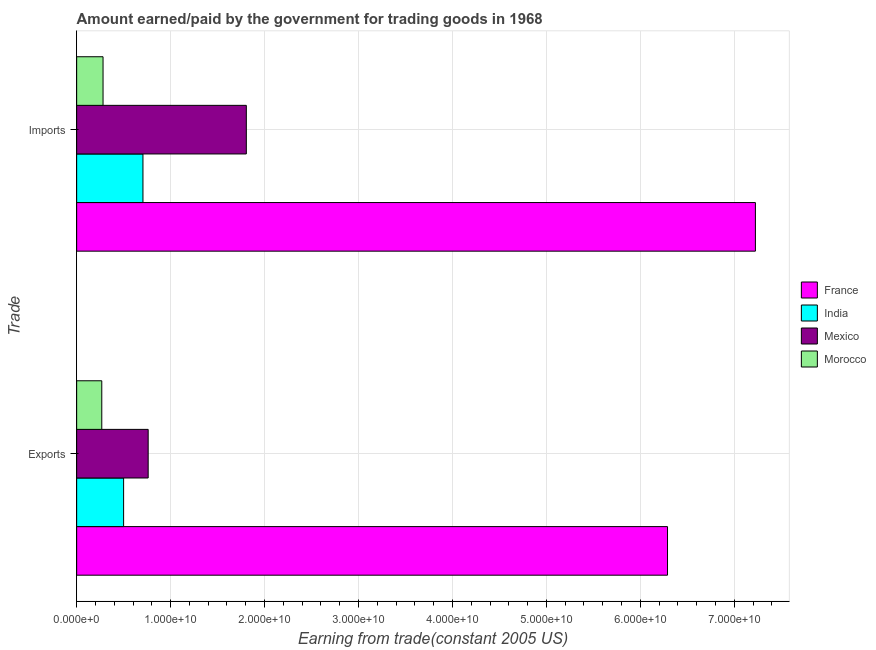Are the number of bars per tick equal to the number of legend labels?
Offer a very short reply. Yes. Are the number of bars on each tick of the Y-axis equal?
Give a very brief answer. Yes. How many bars are there on the 2nd tick from the top?
Make the answer very short. 4. How many bars are there on the 2nd tick from the bottom?
Provide a succinct answer. 4. What is the label of the 2nd group of bars from the top?
Make the answer very short. Exports. What is the amount paid for imports in France?
Your answer should be very brief. 7.22e+1. Across all countries, what is the maximum amount paid for imports?
Offer a very short reply. 7.22e+1. Across all countries, what is the minimum amount earned from exports?
Your response must be concise. 2.67e+09. In which country was the amount paid for imports maximum?
Keep it short and to the point. France. In which country was the amount paid for imports minimum?
Make the answer very short. Morocco. What is the total amount paid for imports in the graph?
Provide a short and direct response. 1.00e+11. What is the difference between the amount earned from exports in Mexico and that in France?
Offer a very short reply. -5.53e+1. What is the difference between the amount earned from exports in Morocco and the amount paid for imports in Mexico?
Offer a very short reply. -1.54e+1. What is the average amount earned from exports per country?
Provide a succinct answer. 1.95e+1. What is the difference between the amount earned from exports and amount paid for imports in India?
Offer a very short reply. -2.06e+09. What is the ratio of the amount paid for imports in France to that in Morocco?
Provide a short and direct response. 25.72. Is the amount earned from exports in India less than that in Morocco?
Provide a succinct answer. No. In how many countries, is the amount paid for imports greater than the average amount paid for imports taken over all countries?
Offer a terse response. 1. What does the 2nd bar from the top in Exports represents?
Give a very brief answer. Mexico. What does the 4th bar from the bottom in Exports represents?
Ensure brevity in your answer.  Morocco. Are all the bars in the graph horizontal?
Give a very brief answer. Yes. How many countries are there in the graph?
Keep it short and to the point. 4. What is the difference between two consecutive major ticks on the X-axis?
Your response must be concise. 1.00e+1. Does the graph contain any zero values?
Make the answer very short. No. Does the graph contain grids?
Offer a terse response. Yes. Where does the legend appear in the graph?
Offer a terse response. Center right. How are the legend labels stacked?
Offer a terse response. Vertical. What is the title of the graph?
Offer a very short reply. Amount earned/paid by the government for trading goods in 1968. What is the label or title of the X-axis?
Your answer should be very brief. Earning from trade(constant 2005 US). What is the label or title of the Y-axis?
Provide a short and direct response. Trade. What is the Earning from trade(constant 2005 US) in France in Exports?
Your answer should be compact. 6.29e+1. What is the Earning from trade(constant 2005 US) in India in Exports?
Provide a succinct answer. 5.00e+09. What is the Earning from trade(constant 2005 US) of Mexico in Exports?
Provide a short and direct response. 7.61e+09. What is the Earning from trade(constant 2005 US) of Morocco in Exports?
Make the answer very short. 2.67e+09. What is the Earning from trade(constant 2005 US) of France in Imports?
Your answer should be compact. 7.22e+1. What is the Earning from trade(constant 2005 US) in India in Imports?
Offer a very short reply. 7.06e+09. What is the Earning from trade(constant 2005 US) in Mexico in Imports?
Offer a very short reply. 1.81e+1. What is the Earning from trade(constant 2005 US) in Morocco in Imports?
Provide a short and direct response. 2.81e+09. Across all Trade, what is the maximum Earning from trade(constant 2005 US) of France?
Your answer should be compact. 7.22e+1. Across all Trade, what is the maximum Earning from trade(constant 2005 US) of India?
Give a very brief answer. 7.06e+09. Across all Trade, what is the maximum Earning from trade(constant 2005 US) of Mexico?
Give a very brief answer. 1.81e+1. Across all Trade, what is the maximum Earning from trade(constant 2005 US) in Morocco?
Offer a terse response. 2.81e+09. Across all Trade, what is the minimum Earning from trade(constant 2005 US) in France?
Keep it short and to the point. 6.29e+1. Across all Trade, what is the minimum Earning from trade(constant 2005 US) of India?
Provide a succinct answer. 5.00e+09. Across all Trade, what is the minimum Earning from trade(constant 2005 US) in Mexico?
Ensure brevity in your answer.  7.61e+09. Across all Trade, what is the minimum Earning from trade(constant 2005 US) of Morocco?
Your response must be concise. 2.67e+09. What is the total Earning from trade(constant 2005 US) of France in the graph?
Make the answer very short. 1.35e+11. What is the total Earning from trade(constant 2005 US) in India in the graph?
Ensure brevity in your answer.  1.21e+1. What is the total Earning from trade(constant 2005 US) in Mexico in the graph?
Offer a terse response. 2.57e+1. What is the total Earning from trade(constant 2005 US) of Morocco in the graph?
Your response must be concise. 5.48e+09. What is the difference between the Earning from trade(constant 2005 US) in France in Exports and that in Imports?
Keep it short and to the point. -9.36e+09. What is the difference between the Earning from trade(constant 2005 US) of India in Exports and that in Imports?
Your answer should be very brief. -2.06e+09. What is the difference between the Earning from trade(constant 2005 US) of Mexico in Exports and that in Imports?
Your response must be concise. -1.04e+1. What is the difference between the Earning from trade(constant 2005 US) in Morocco in Exports and that in Imports?
Keep it short and to the point. -1.35e+08. What is the difference between the Earning from trade(constant 2005 US) in France in Exports and the Earning from trade(constant 2005 US) in India in Imports?
Make the answer very short. 5.58e+1. What is the difference between the Earning from trade(constant 2005 US) in France in Exports and the Earning from trade(constant 2005 US) in Mexico in Imports?
Give a very brief answer. 4.48e+1. What is the difference between the Earning from trade(constant 2005 US) of France in Exports and the Earning from trade(constant 2005 US) of Morocco in Imports?
Give a very brief answer. 6.01e+1. What is the difference between the Earning from trade(constant 2005 US) in India in Exports and the Earning from trade(constant 2005 US) in Mexico in Imports?
Make the answer very short. -1.31e+1. What is the difference between the Earning from trade(constant 2005 US) in India in Exports and the Earning from trade(constant 2005 US) in Morocco in Imports?
Offer a terse response. 2.19e+09. What is the difference between the Earning from trade(constant 2005 US) of Mexico in Exports and the Earning from trade(constant 2005 US) of Morocco in Imports?
Provide a succinct answer. 4.80e+09. What is the average Earning from trade(constant 2005 US) of France per Trade?
Your answer should be very brief. 6.76e+1. What is the average Earning from trade(constant 2005 US) of India per Trade?
Offer a very short reply. 6.03e+09. What is the average Earning from trade(constant 2005 US) of Mexico per Trade?
Your answer should be very brief. 1.28e+1. What is the average Earning from trade(constant 2005 US) in Morocco per Trade?
Your answer should be compact. 2.74e+09. What is the difference between the Earning from trade(constant 2005 US) in France and Earning from trade(constant 2005 US) in India in Exports?
Make the answer very short. 5.79e+1. What is the difference between the Earning from trade(constant 2005 US) in France and Earning from trade(constant 2005 US) in Mexico in Exports?
Your response must be concise. 5.53e+1. What is the difference between the Earning from trade(constant 2005 US) of France and Earning from trade(constant 2005 US) of Morocco in Exports?
Your answer should be compact. 6.02e+1. What is the difference between the Earning from trade(constant 2005 US) in India and Earning from trade(constant 2005 US) in Mexico in Exports?
Give a very brief answer. -2.61e+09. What is the difference between the Earning from trade(constant 2005 US) of India and Earning from trade(constant 2005 US) of Morocco in Exports?
Provide a succinct answer. 2.32e+09. What is the difference between the Earning from trade(constant 2005 US) of Mexico and Earning from trade(constant 2005 US) of Morocco in Exports?
Your answer should be compact. 4.94e+09. What is the difference between the Earning from trade(constant 2005 US) of France and Earning from trade(constant 2005 US) of India in Imports?
Give a very brief answer. 6.52e+1. What is the difference between the Earning from trade(constant 2005 US) of France and Earning from trade(constant 2005 US) of Mexico in Imports?
Make the answer very short. 5.42e+1. What is the difference between the Earning from trade(constant 2005 US) of France and Earning from trade(constant 2005 US) of Morocco in Imports?
Your answer should be very brief. 6.94e+1. What is the difference between the Earning from trade(constant 2005 US) of India and Earning from trade(constant 2005 US) of Mexico in Imports?
Make the answer very short. -1.10e+1. What is the difference between the Earning from trade(constant 2005 US) of India and Earning from trade(constant 2005 US) of Morocco in Imports?
Provide a succinct answer. 4.25e+09. What is the difference between the Earning from trade(constant 2005 US) of Mexico and Earning from trade(constant 2005 US) of Morocco in Imports?
Provide a succinct answer. 1.53e+1. What is the ratio of the Earning from trade(constant 2005 US) of France in Exports to that in Imports?
Provide a short and direct response. 0.87. What is the ratio of the Earning from trade(constant 2005 US) of India in Exports to that in Imports?
Provide a short and direct response. 0.71. What is the ratio of the Earning from trade(constant 2005 US) of Mexico in Exports to that in Imports?
Give a very brief answer. 0.42. What is the difference between the highest and the second highest Earning from trade(constant 2005 US) of France?
Your answer should be very brief. 9.36e+09. What is the difference between the highest and the second highest Earning from trade(constant 2005 US) in India?
Ensure brevity in your answer.  2.06e+09. What is the difference between the highest and the second highest Earning from trade(constant 2005 US) in Mexico?
Your answer should be very brief. 1.04e+1. What is the difference between the highest and the second highest Earning from trade(constant 2005 US) of Morocco?
Your response must be concise. 1.35e+08. What is the difference between the highest and the lowest Earning from trade(constant 2005 US) of France?
Give a very brief answer. 9.36e+09. What is the difference between the highest and the lowest Earning from trade(constant 2005 US) in India?
Offer a terse response. 2.06e+09. What is the difference between the highest and the lowest Earning from trade(constant 2005 US) of Mexico?
Provide a short and direct response. 1.04e+1. What is the difference between the highest and the lowest Earning from trade(constant 2005 US) in Morocco?
Your response must be concise. 1.35e+08. 